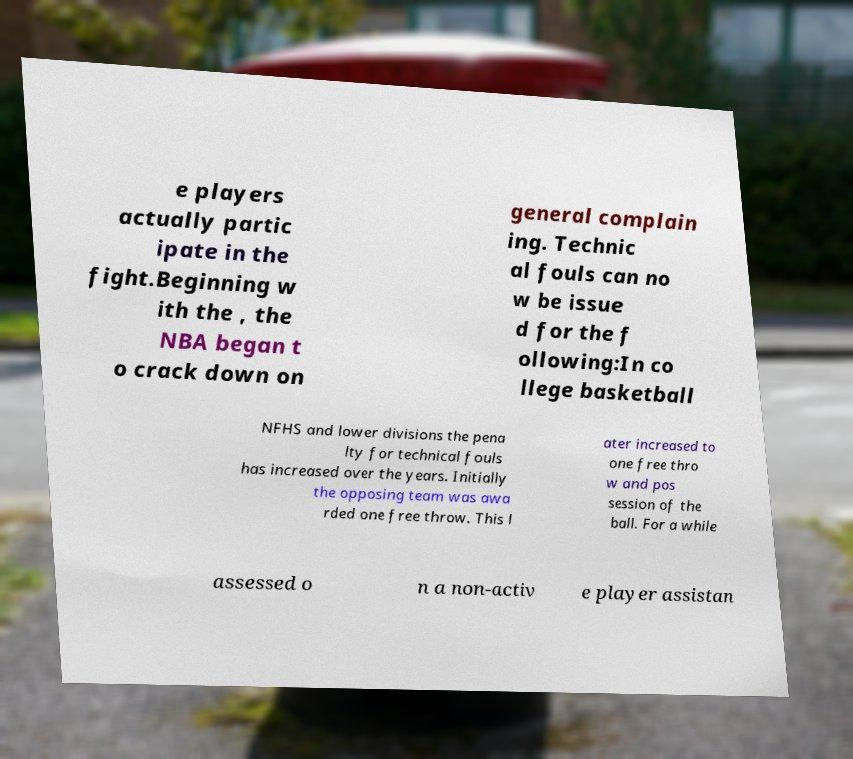Please read and relay the text visible in this image. What does it say? e players actually partic ipate in the fight.Beginning w ith the , the NBA began t o crack down on general complain ing. Technic al fouls can no w be issue d for the f ollowing:In co llege basketball NFHS and lower divisions the pena lty for technical fouls has increased over the years. Initially the opposing team was awa rded one free throw. This l ater increased to one free thro w and pos session of the ball. For a while assessed o n a non-activ e player assistan 